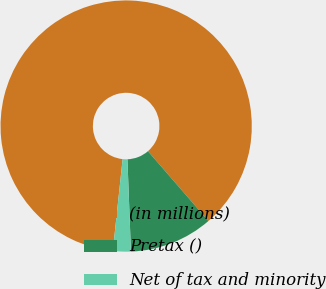Convert chart to OTSL. <chart><loc_0><loc_0><loc_500><loc_500><pie_chart><fcel>(in millions)<fcel>Pretax ()<fcel>Net of tax and minority<nl><fcel>86.94%<fcel>10.76%<fcel>2.3%<nl></chart> 